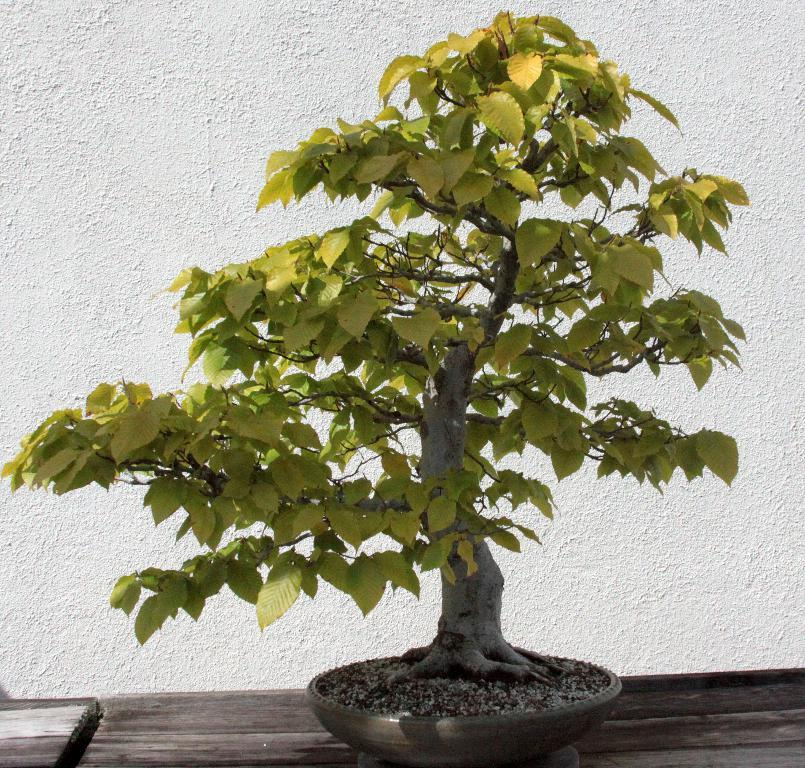What is the main subject in the center of the image? There is a plant in the center of the image. What type of surface is the plant placed on? The plant is on a wooden surface. What can be seen in the background of the image? There is a wall in the background of the image. What type of bag is hanging on the wall in the image? There is no bag present in the image; it only features a plant on a wooden surface and a wall in the background. 